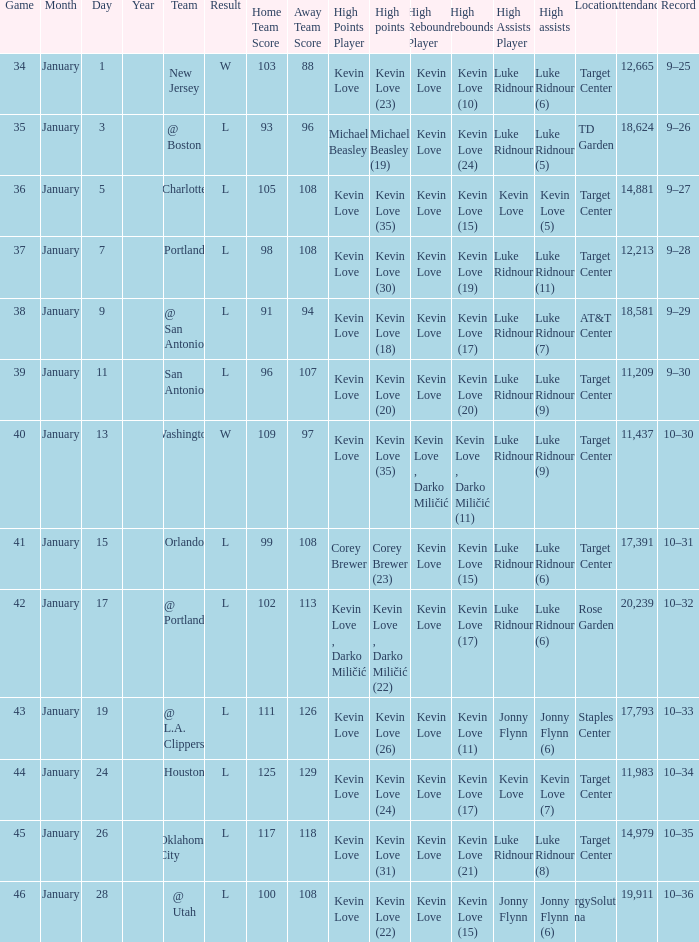What is the highest game with team @ l.a. clippers? 43.0. 